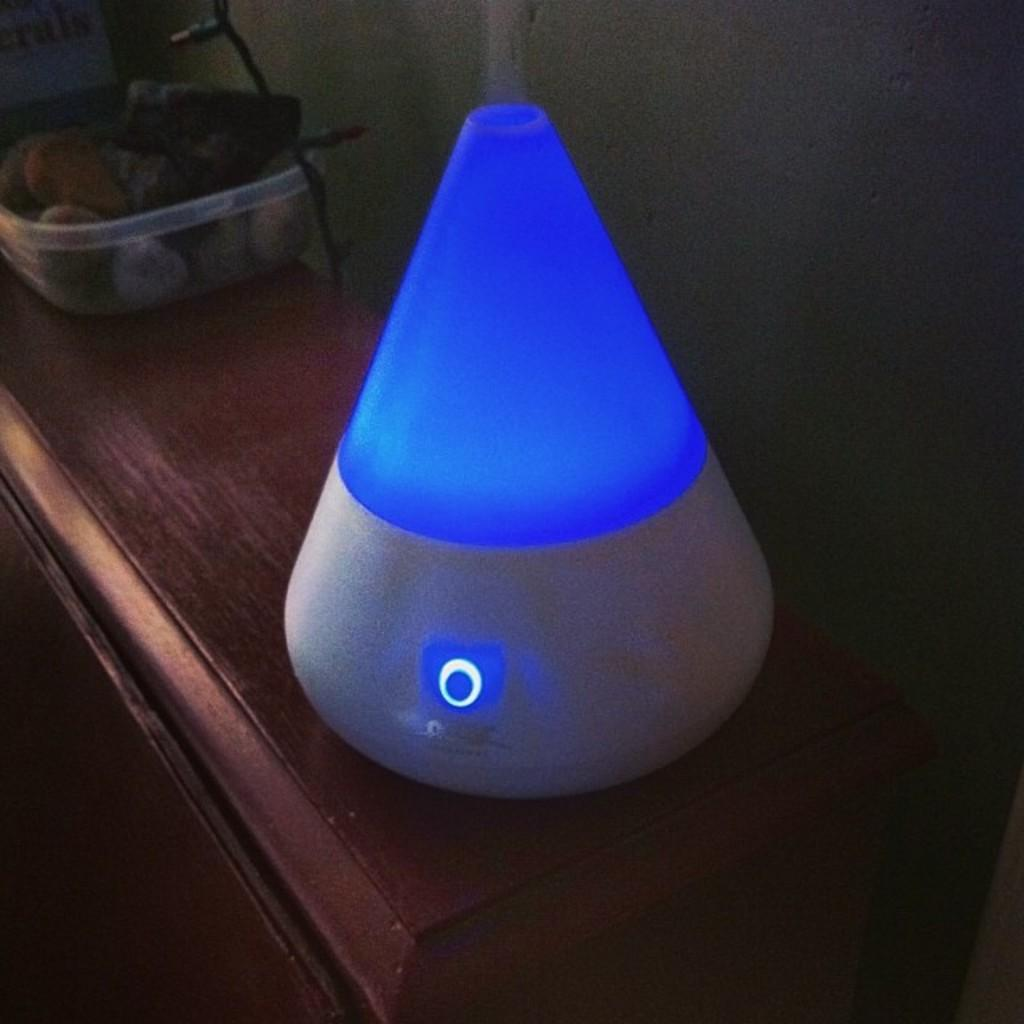What type of electronic device is in the image? The specific type of electronic device is not mentioned, but there is an electronic device in the image. What food items are in the image? There are fruits in a bowl in the image. What is the surface made of that the fruits are on? The fruits are on a wooden surface. What type of lighting is present in the image? There are serial lights in the image. What can be seen in the background of the image? There is a wall visible in the image. How many nuts are on the cherry tree in the image? There is no cherry tree or nuts present in the image. What type of authority figure is depicted in the image? There is no authority figure depicted in the image. 